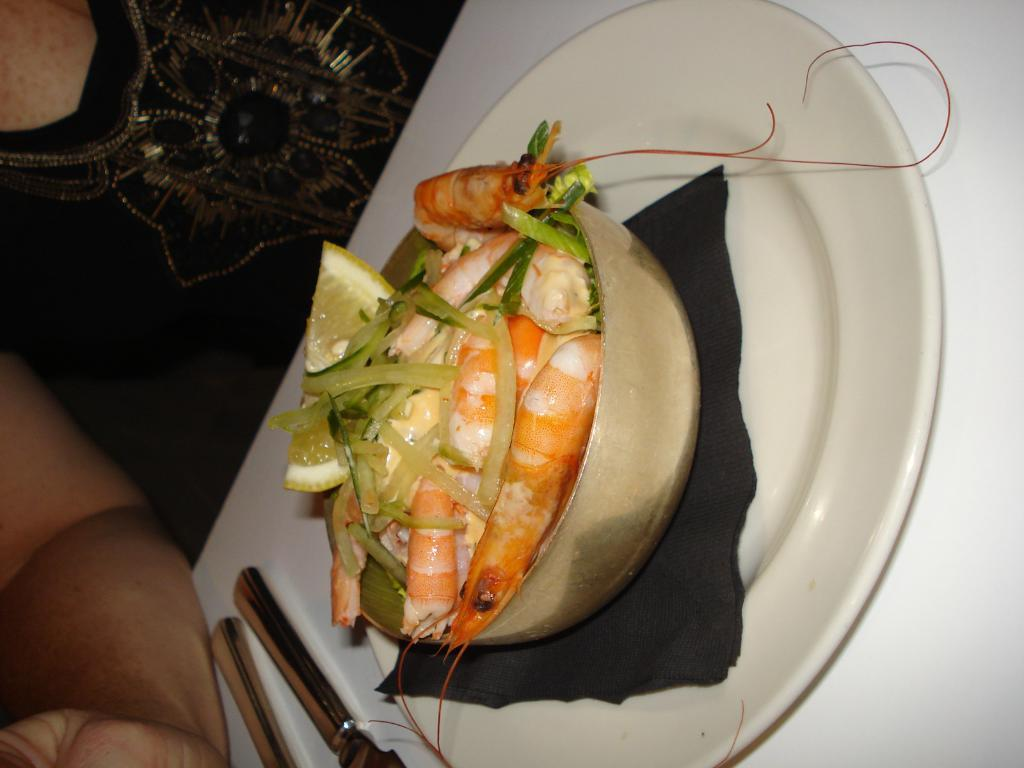What type of living being is present in the image? There is a human in the image. What else can be seen in the image besides the human? There is food in the image, specifically lemon pieces in a bowl on a plate. What utensil is present on the table in the image? There is a knife on the table. What type of shoe can be seen in the image? There is no shoe present in the image. What type of waste is visible in the image? There is no waste visible in the image. 